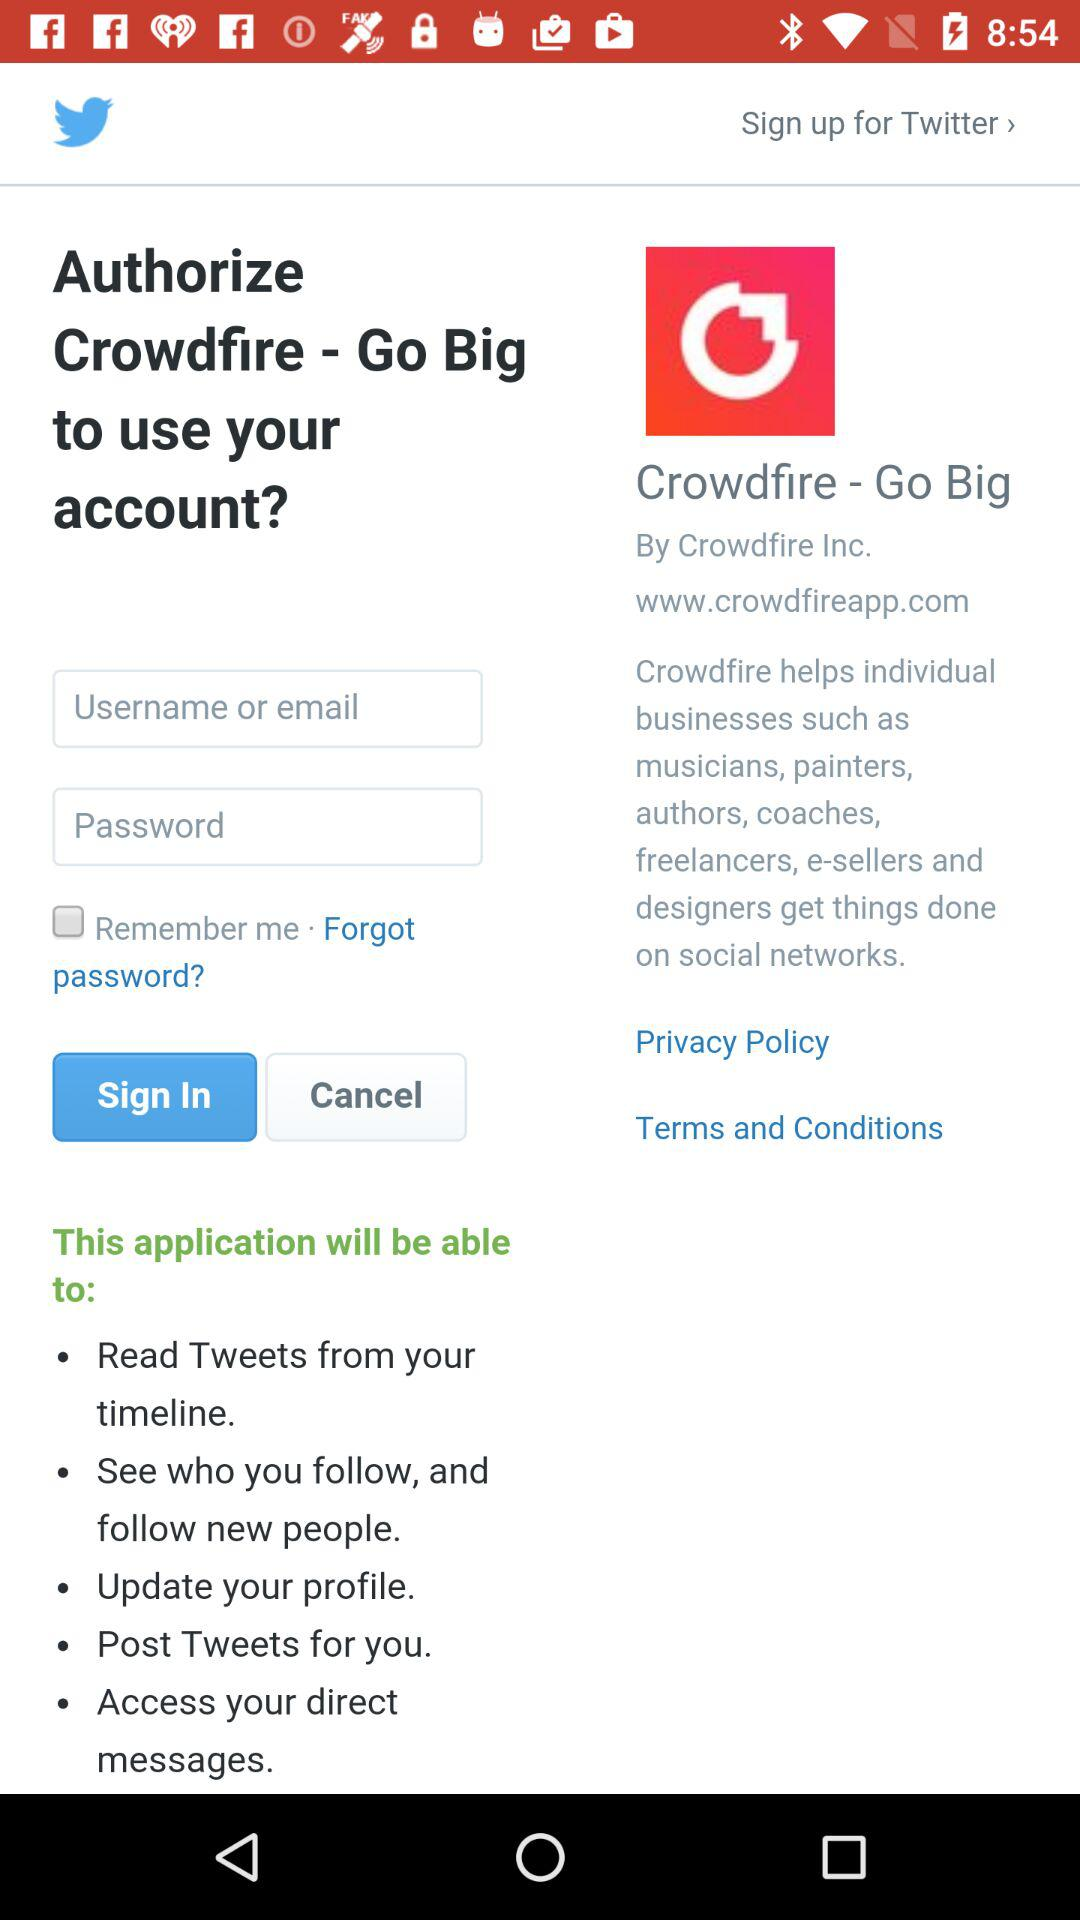Which application can we sign up for? You can sign up for "Twitter". 